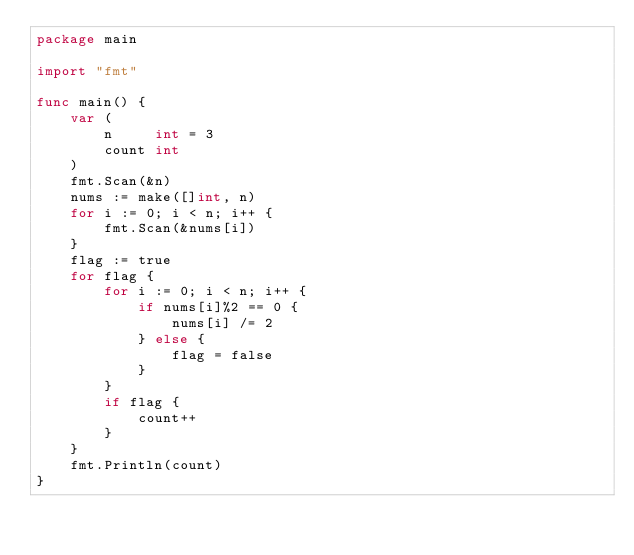<code> <loc_0><loc_0><loc_500><loc_500><_Go_>package main

import "fmt"

func main() {
	var (
		n     int = 3
		count int
	)
	fmt.Scan(&n)
	nums := make([]int, n)
	for i := 0; i < n; i++ {
		fmt.Scan(&nums[i])
	}
	flag := true
	for flag {
		for i := 0; i < n; i++ {
			if nums[i]%2 == 0 {
				nums[i] /= 2
			} else {
				flag = false
			}
		}
		if flag {
			count++
		}
	}
	fmt.Println(count)
}</code> 